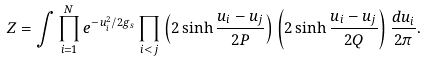<formula> <loc_0><loc_0><loc_500><loc_500>Z = \int \prod _ { i = 1 } ^ { N } e ^ { - u _ { i } ^ { 2 } / 2 g _ { s } } \prod _ { i < j } \left ( 2 \sinh \frac { u _ { i } - u _ { j } } { 2 P } \right ) \left ( 2 \sinh \frac { u _ { i } - u _ { j } } { 2 Q } \right ) \frac { d u _ { i } } { 2 \pi } .</formula> 